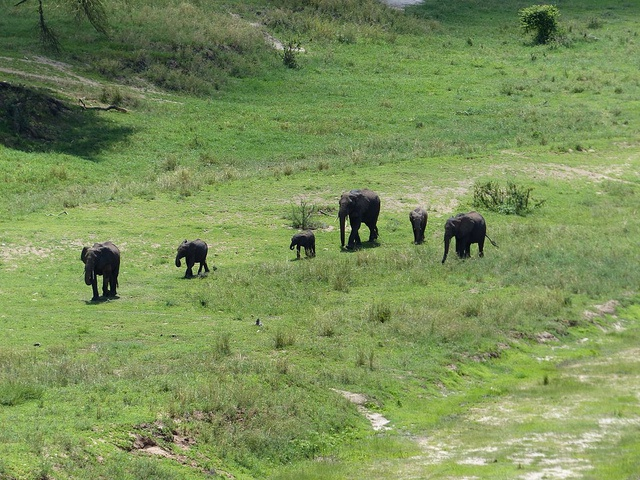Describe the objects in this image and their specific colors. I can see elephant in darkgreen, black, olive, gray, and darkgray tones, elephant in darkgreen, black, gray, darkgray, and olive tones, elephant in darkgreen, black, and gray tones, elephant in darkgreen, black, gray, olive, and darkgray tones, and elephant in darkgreen, black, olive, and gray tones in this image. 